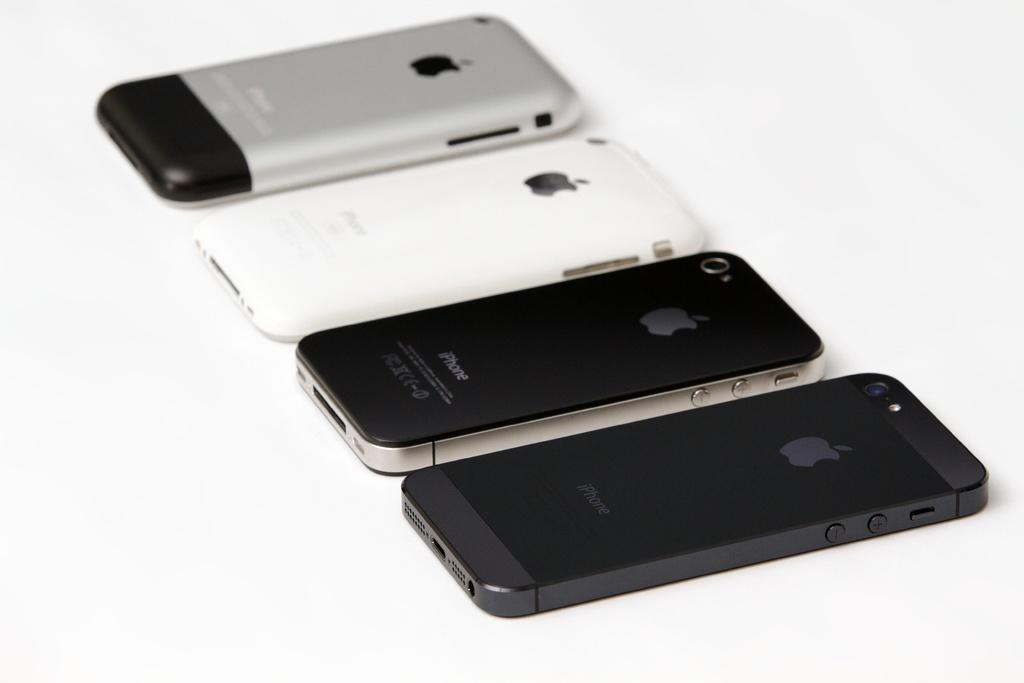<image>
Provide a brief description of the given image. Four different generation iPhones are all laid out next to each other. 